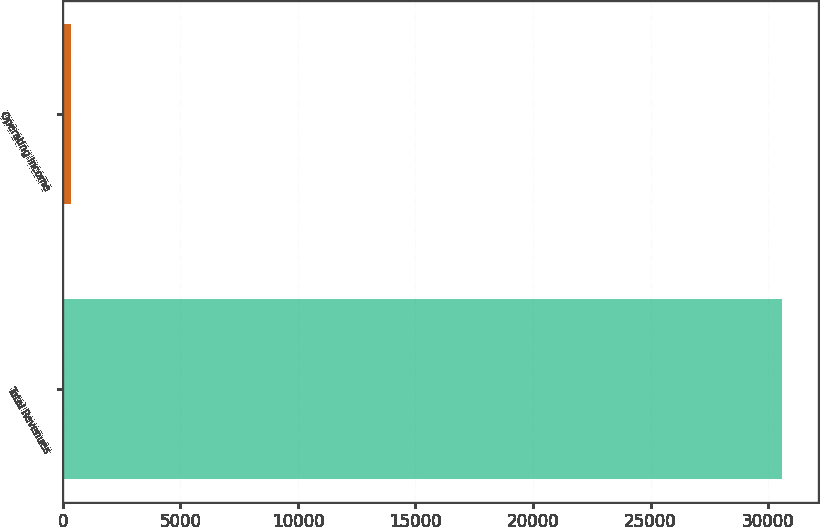Convert chart. <chart><loc_0><loc_0><loc_500><loc_500><bar_chart><fcel>Total Revenues<fcel>Operating Income<nl><fcel>30596<fcel>327<nl></chart> 